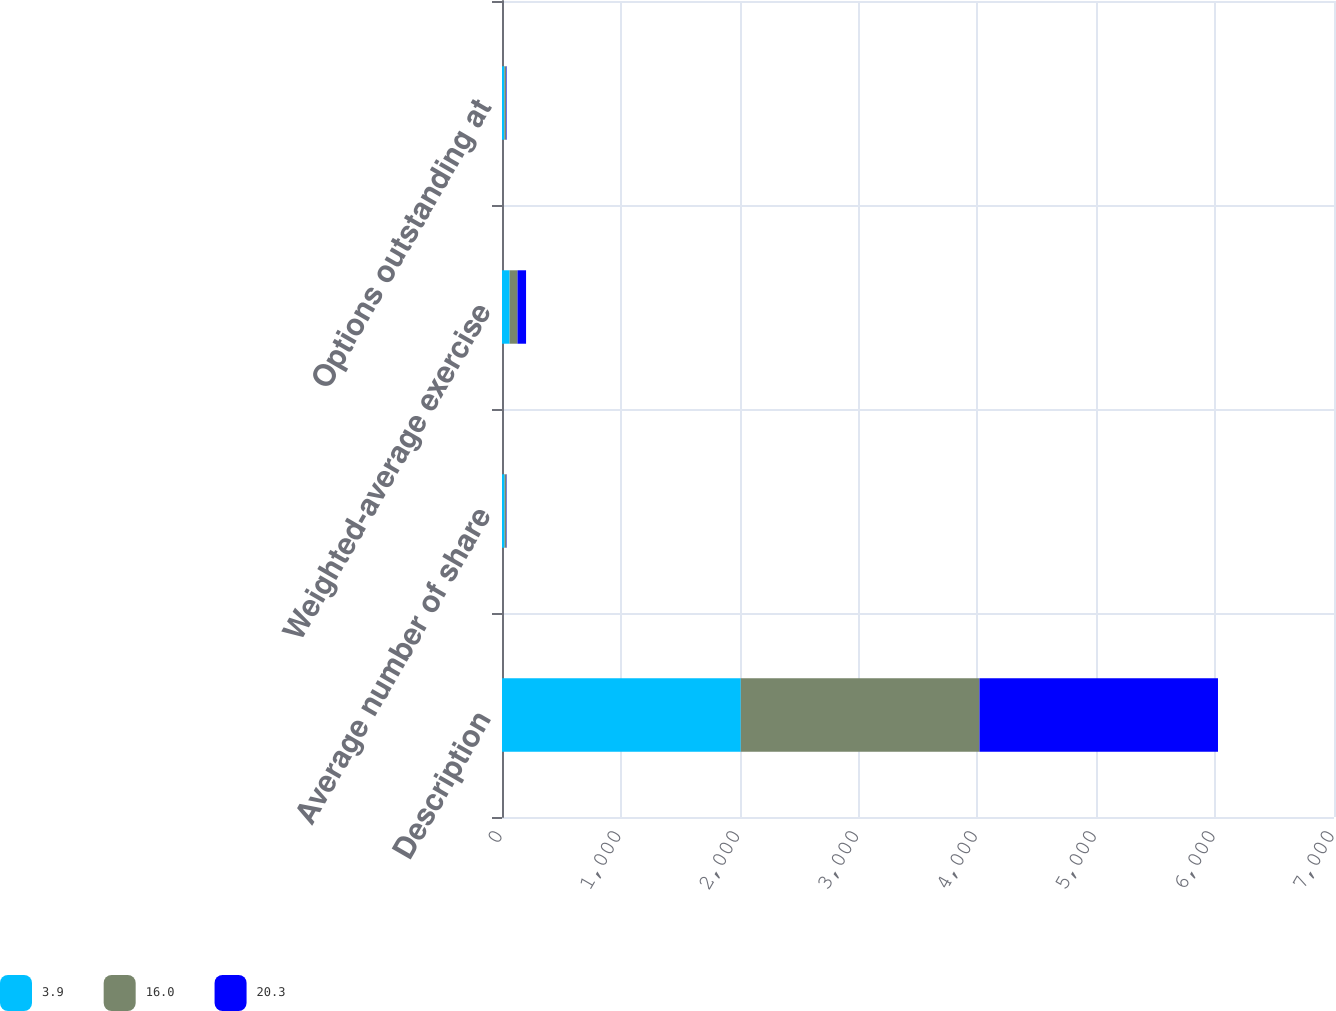<chart> <loc_0><loc_0><loc_500><loc_500><stacked_bar_chart><ecel><fcel>Description<fcel>Average number of share<fcel>Weighted-average exercise<fcel>Options outstanding at<nl><fcel>3.9<fcel>2009<fcel>21.8<fcel>64.12<fcel>20.3<nl><fcel>16<fcel>2008<fcel>15.6<fcel>66.31<fcel>16<nl><fcel>20.3<fcel>2007<fcel>2.8<fcel>72<fcel>3.9<nl></chart> 